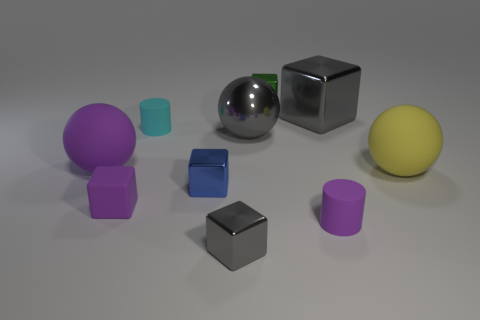There is a large object that is the same color as the large cube; what material is it?
Provide a short and direct response. Metal. There is a big object that is the same color as the matte block; what is its shape?
Your answer should be compact. Sphere. How big is the metallic block that is both on the left side of the large gray block and behind the small cyan matte cylinder?
Ensure brevity in your answer.  Small. Are there any tiny purple cylinders on the right side of the big gray shiny sphere?
Offer a very short reply. Yes. What number of things are gray metal blocks that are behind the cyan rubber thing or green matte cylinders?
Give a very brief answer. 1. How many shiny cubes are to the right of the small matte object right of the metallic ball?
Provide a short and direct response. 1. Are there fewer small purple cylinders behind the matte cube than cyan matte objects that are to the right of the tiny purple cylinder?
Offer a terse response. No. There is a big object that is behind the small matte thing that is behind the large metallic ball; what is its shape?
Provide a short and direct response. Cube. What number of other objects are the same material as the small purple cylinder?
Your response must be concise. 4. Are there any other things that have the same size as the purple matte block?
Offer a terse response. Yes. 